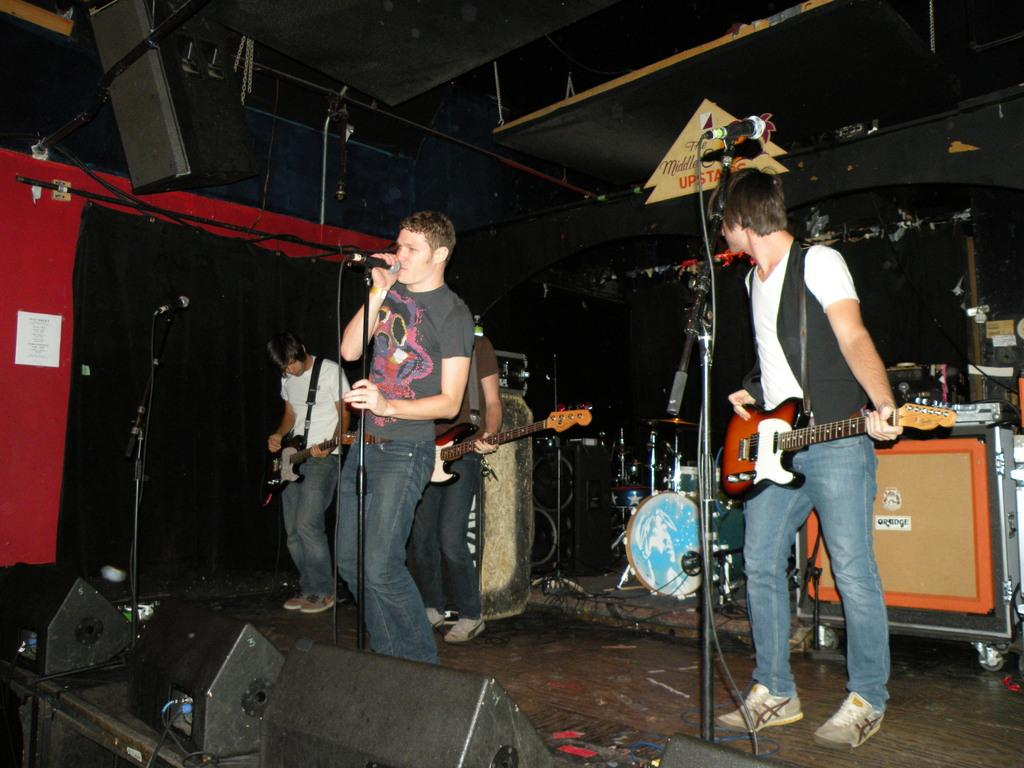How many people are on the stage in the image? There are 4 people on the stage. What are the people at the back doing? Three people at the back are playing guitar. What is the person at the front doing? The person at the front is singing in the microphone. What other musical instrument can be seen on the stage? There are drums at the back. What type of ornament is hanging from the microphone in the image? There is no ornament hanging from the microphone in the image. Can you tell me how many jelly containers are visible on the stage? There are no jelly containers visible on the stage in the image. 